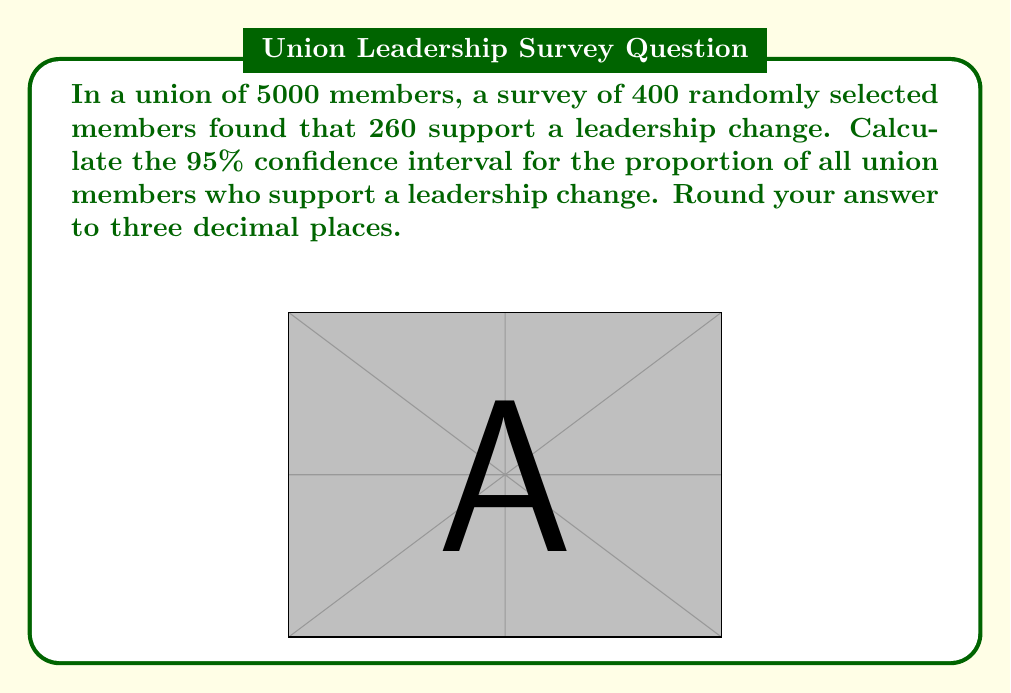Help me with this question. Let's approach this step-by-step:

1) First, we need to calculate the sample proportion:
   $\hat{p} = \frac{260}{400} = 0.65$

2) The formula for the confidence interval is:
   $$\hat{p} \pm z_{\alpha/2} \sqrt{\frac{\hat{p}(1-\hat{p})}{n}}$$
   where $z_{\alpha/2}$ is the critical value for the desired confidence level.

3) For a 95% confidence interval, $z_{\alpha/2} = 1.96$

4) Now, let's substitute the values:
   $n = 400$
   $\hat{p} = 0.65$

5) Calculate the standard error:
   $$SE = \sqrt{\frac{\hat{p}(1-\hat{p})}{n}} = \sqrt{\frac{0.65(1-0.65)}{400}} = 0.0238$$

6) Now, we can calculate the margin of error:
   $$ME = 1.96 \times 0.0238 = 0.0467$$

7) Finally, we can compute the confidence interval:
   Lower bound: $0.65 - 0.0467 = 0.6033$
   Upper bound: $0.65 + 0.0467 = 0.6967$

8) Rounding to three decimal places:
   (0.603, 0.697)

This means we can be 95% confident that the true proportion of all union members who support a leadership change is between 60.3% and 69.7%.
Answer: (0.603, 0.697) 